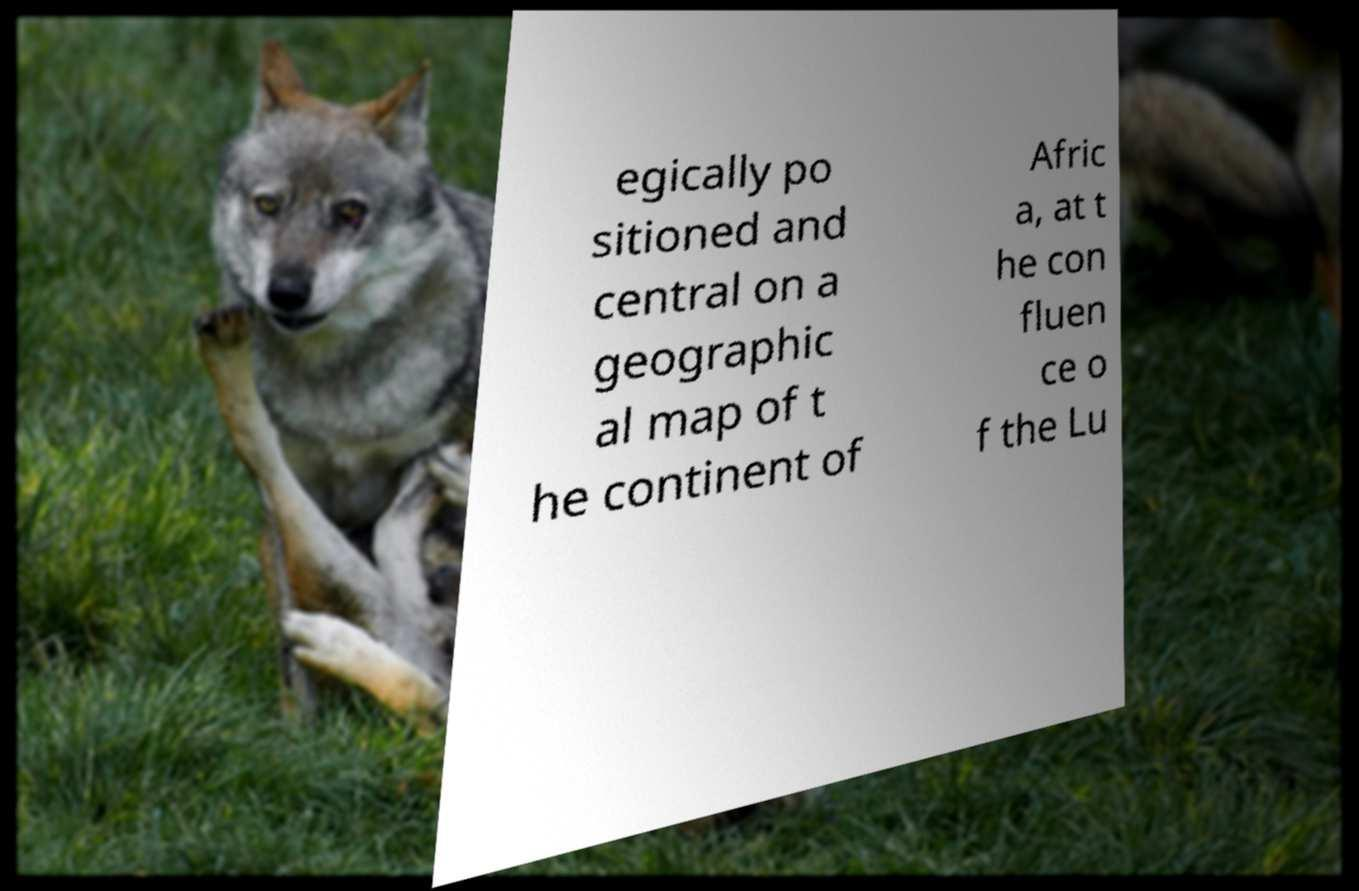There's text embedded in this image that I need extracted. Can you transcribe it verbatim? egically po sitioned and central on a geographic al map of t he continent of Afric a, at t he con fluen ce o f the Lu 